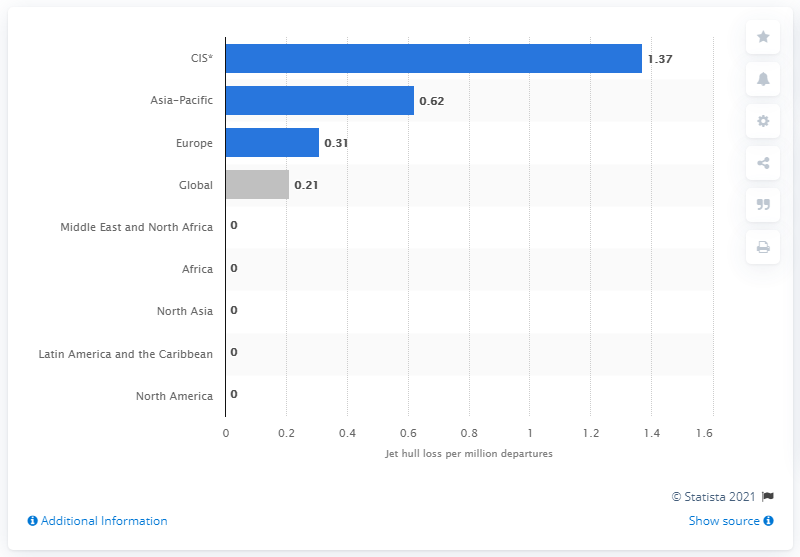Highlight a few significant elements in this photo. There were 1.37 jet accidents per one million flights in the Commonwealth of Independent States in 2020. 